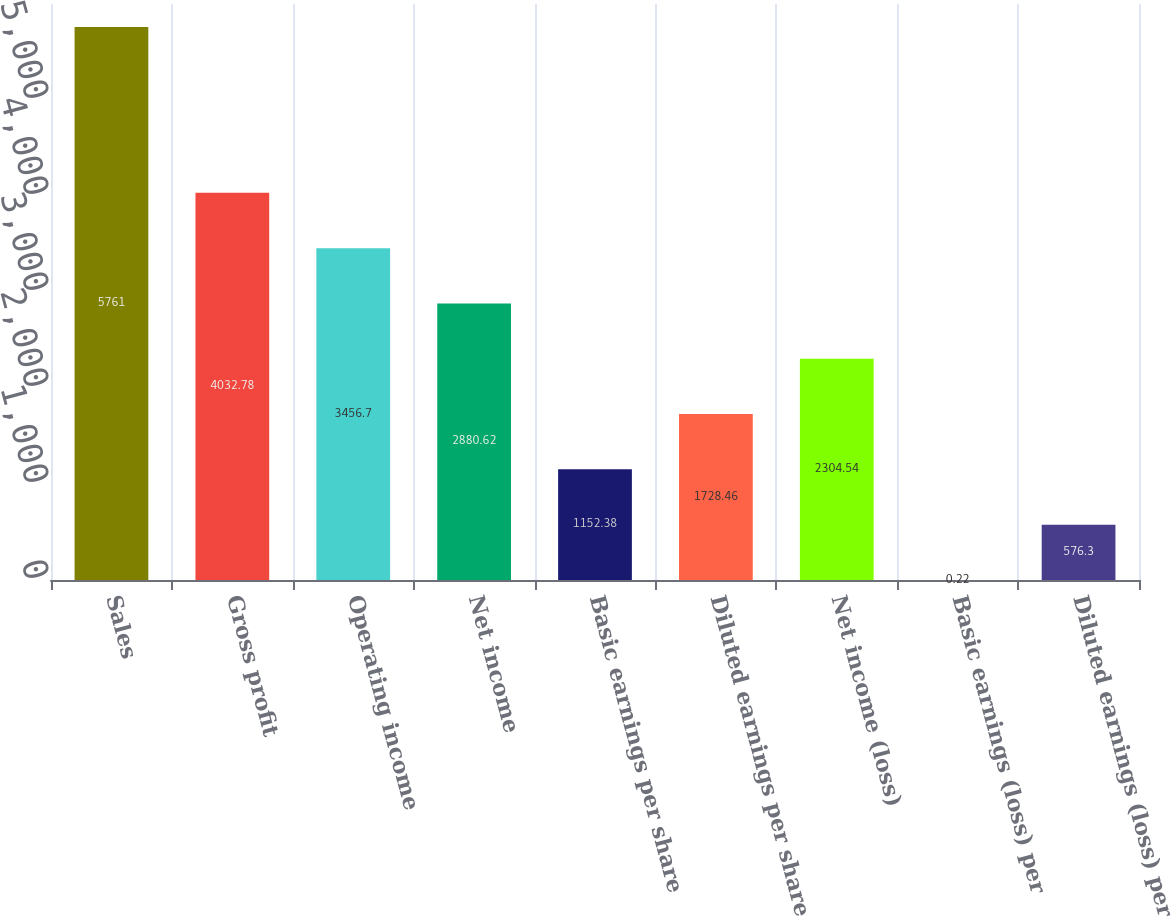<chart> <loc_0><loc_0><loc_500><loc_500><bar_chart><fcel>Sales<fcel>Gross profit<fcel>Operating income<fcel>Net income<fcel>Basic earnings per share<fcel>Diluted earnings per share<fcel>Net income (loss)<fcel>Basic earnings (loss) per<fcel>Diluted earnings (loss) per<nl><fcel>5761<fcel>4032.78<fcel>3456.7<fcel>2880.62<fcel>1152.38<fcel>1728.46<fcel>2304.54<fcel>0.22<fcel>576.3<nl></chart> 